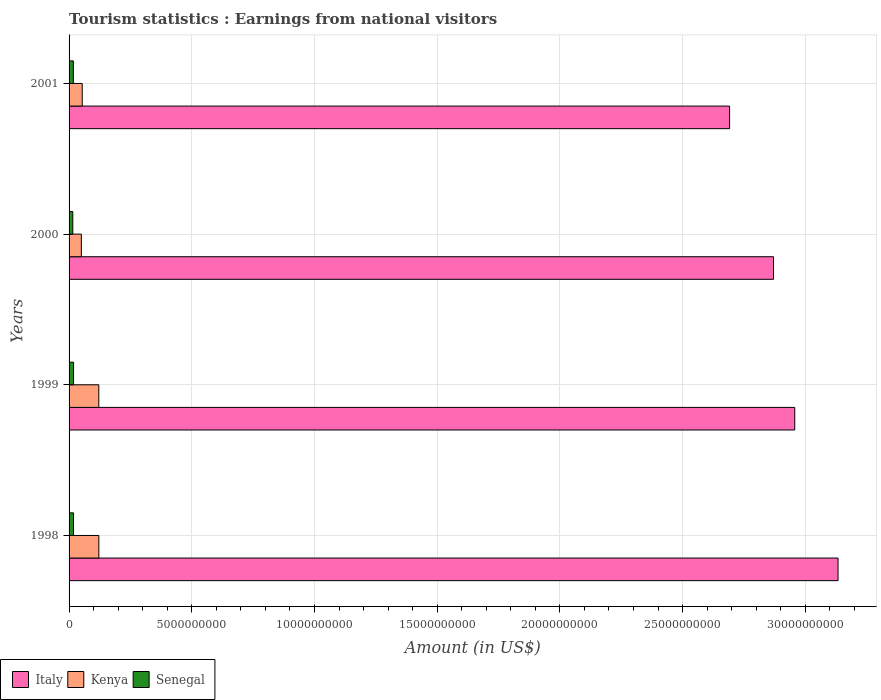Are the number of bars per tick equal to the number of legend labels?
Provide a succinct answer. Yes. Are the number of bars on each tick of the Y-axis equal?
Offer a terse response. Yes. How many bars are there on the 2nd tick from the top?
Provide a succinct answer. 3. In how many cases, is the number of bars for a given year not equal to the number of legend labels?
Give a very brief answer. 0. What is the earnings from national visitors in Kenya in 1999?
Keep it short and to the point. 1.21e+09. Across all years, what is the maximum earnings from national visitors in Italy?
Give a very brief answer. 3.13e+1. Across all years, what is the minimum earnings from national visitors in Senegal?
Keep it short and to the point. 1.52e+08. What is the total earnings from national visitors in Italy in the graph?
Your answer should be very brief. 1.17e+11. What is the difference between the earnings from national visitors in Italy in 1998 and that in 2001?
Offer a very short reply. 4.42e+09. What is the difference between the earnings from national visitors in Kenya in 1999 and the earnings from national visitors in Italy in 2001?
Offer a terse response. -2.57e+1. What is the average earnings from national visitors in Kenya per year?
Offer a very short reply. 8.65e+08. In the year 2001, what is the difference between the earnings from national visitors in Italy and earnings from national visitors in Senegal?
Keep it short and to the point. 2.67e+1. In how many years, is the earnings from national visitors in Kenya greater than 26000000000 US$?
Your answer should be very brief. 0. What is the ratio of the earnings from national visitors in Italy in 1998 to that in 2001?
Offer a terse response. 1.16. What is the difference between the highest and the second highest earnings from national visitors in Italy?
Give a very brief answer. 1.76e+09. What is the difference between the highest and the lowest earnings from national visitors in Italy?
Your response must be concise. 4.42e+09. What does the 3rd bar from the top in 1999 represents?
Keep it short and to the point. Italy. What does the 2nd bar from the bottom in 1998 represents?
Your response must be concise. Kenya. Is it the case that in every year, the sum of the earnings from national visitors in Kenya and earnings from national visitors in Senegal is greater than the earnings from national visitors in Italy?
Make the answer very short. No. Are all the bars in the graph horizontal?
Provide a succinct answer. Yes. What is the difference between two consecutive major ticks on the X-axis?
Make the answer very short. 5.00e+09. Are the values on the major ticks of X-axis written in scientific E-notation?
Make the answer very short. No. Does the graph contain grids?
Keep it short and to the point. Yes. How many legend labels are there?
Ensure brevity in your answer.  3. How are the legend labels stacked?
Provide a succinct answer. Horizontal. What is the title of the graph?
Give a very brief answer. Tourism statistics : Earnings from national visitors. What is the Amount (in US$) of Italy in 1998?
Offer a very short reply. 3.13e+1. What is the Amount (in US$) of Kenya in 1998?
Your answer should be compact. 1.21e+09. What is the Amount (in US$) in Senegal in 1998?
Ensure brevity in your answer.  1.81e+08. What is the Amount (in US$) of Italy in 1999?
Offer a terse response. 2.96e+1. What is the Amount (in US$) in Kenya in 1999?
Your answer should be compact. 1.21e+09. What is the Amount (in US$) in Senegal in 1999?
Provide a short and direct response. 1.83e+08. What is the Amount (in US$) in Italy in 2000?
Provide a succinct answer. 2.87e+1. What is the Amount (in US$) of Senegal in 2000?
Make the answer very short. 1.52e+08. What is the Amount (in US$) of Italy in 2001?
Make the answer very short. 2.69e+1. What is the Amount (in US$) of Kenya in 2001?
Make the answer very short. 5.36e+08. What is the Amount (in US$) in Senegal in 2001?
Ensure brevity in your answer.  1.75e+08. Across all years, what is the maximum Amount (in US$) in Italy?
Offer a very short reply. 3.13e+1. Across all years, what is the maximum Amount (in US$) of Kenya?
Make the answer very short. 1.21e+09. Across all years, what is the maximum Amount (in US$) in Senegal?
Give a very brief answer. 1.83e+08. Across all years, what is the minimum Amount (in US$) of Italy?
Your answer should be very brief. 2.69e+1. Across all years, what is the minimum Amount (in US$) of Kenya?
Keep it short and to the point. 5.00e+08. Across all years, what is the minimum Amount (in US$) in Senegal?
Keep it short and to the point. 1.52e+08. What is the total Amount (in US$) in Italy in the graph?
Offer a terse response. 1.17e+11. What is the total Amount (in US$) in Kenya in the graph?
Your answer should be compact. 3.46e+09. What is the total Amount (in US$) in Senegal in the graph?
Provide a short and direct response. 6.91e+08. What is the difference between the Amount (in US$) of Italy in 1998 and that in 1999?
Provide a short and direct response. 1.76e+09. What is the difference between the Amount (in US$) in Italy in 1998 and that in 2000?
Give a very brief answer. 2.63e+09. What is the difference between the Amount (in US$) of Kenya in 1998 and that in 2000?
Your answer should be compact. 7.13e+08. What is the difference between the Amount (in US$) in Senegal in 1998 and that in 2000?
Your answer should be very brief. 2.90e+07. What is the difference between the Amount (in US$) of Italy in 1998 and that in 2001?
Provide a short and direct response. 4.42e+09. What is the difference between the Amount (in US$) in Kenya in 1998 and that in 2001?
Your response must be concise. 6.77e+08. What is the difference between the Amount (in US$) in Senegal in 1998 and that in 2001?
Provide a short and direct response. 6.00e+06. What is the difference between the Amount (in US$) in Italy in 1999 and that in 2000?
Provide a succinct answer. 8.65e+08. What is the difference between the Amount (in US$) of Kenya in 1999 and that in 2000?
Your response must be concise. 7.11e+08. What is the difference between the Amount (in US$) in Senegal in 1999 and that in 2000?
Your answer should be compact. 3.10e+07. What is the difference between the Amount (in US$) in Italy in 1999 and that in 2001?
Provide a short and direct response. 2.66e+09. What is the difference between the Amount (in US$) of Kenya in 1999 and that in 2001?
Ensure brevity in your answer.  6.75e+08. What is the difference between the Amount (in US$) in Italy in 2000 and that in 2001?
Offer a terse response. 1.79e+09. What is the difference between the Amount (in US$) in Kenya in 2000 and that in 2001?
Ensure brevity in your answer.  -3.60e+07. What is the difference between the Amount (in US$) of Senegal in 2000 and that in 2001?
Give a very brief answer. -2.30e+07. What is the difference between the Amount (in US$) of Italy in 1998 and the Amount (in US$) of Kenya in 1999?
Your answer should be compact. 3.01e+1. What is the difference between the Amount (in US$) of Italy in 1998 and the Amount (in US$) of Senegal in 1999?
Provide a short and direct response. 3.12e+1. What is the difference between the Amount (in US$) of Kenya in 1998 and the Amount (in US$) of Senegal in 1999?
Your response must be concise. 1.03e+09. What is the difference between the Amount (in US$) of Italy in 1998 and the Amount (in US$) of Kenya in 2000?
Ensure brevity in your answer.  3.08e+1. What is the difference between the Amount (in US$) in Italy in 1998 and the Amount (in US$) in Senegal in 2000?
Your answer should be compact. 3.12e+1. What is the difference between the Amount (in US$) in Kenya in 1998 and the Amount (in US$) in Senegal in 2000?
Keep it short and to the point. 1.06e+09. What is the difference between the Amount (in US$) of Italy in 1998 and the Amount (in US$) of Kenya in 2001?
Provide a short and direct response. 3.08e+1. What is the difference between the Amount (in US$) of Italy in 1998 and the Amount (in US$) of Senegal in 2001?
Offer a terse response. 3.12e+1. What is the difference between the Amount (in US$) in Kenya in 1998 and the Amount (in US$) in Senegal in 2001?
Keep it short and to the point. 1.04e+09. What is the difference between the Amount (in US$) in Italy in 1999 and the Amount (in US$) in Kenya in 2000?
Your response must be concise. 2.91e+1. What is the difference between the Amount (in US$) in Italy in 1999 and the Amount (in US$) in Senegal in 2000?
Provide a short and direct response. 2.94e+1. What is the difference between the Amount (in US$) in Kenya in 1999 and the Amount (in US$) in Senegal in 2000?
Your answer should be very brief. 1.06e+09. What is the difference between the Amount (in US$) of Italy in 1999 and the Amount (in US$) of Kenya in 2001?
Make the answer very short. 2.90e+1. What is the difference between the Amount (in US$) of Italy in 1999 and the Amount (in US$) of Senegal in 2001?
Your response must be concise. 2.94e+1. What is the difference between the Amount (in US$) of Kenya in 1999 and the Amount (in US$) of Senegal in 2001?
Your answer should be very brief. 1.04e+09. What is the difference between the Amount (in US$) in Italy in 2000 and the Amount (in US$) in Kenya in 2001?
Offer a very short reply. 2.82e+1. What is the difference between the Amount (in US$) of Italy in 2000 and the Amount (in US$) of Senegal in 2001?
Ensure brevity in your answer.  2.85e+1. What is the difference between the Amount (in US$) of Kenya in 2000 and the Amount (in US$) of Senegal in 2001?
Provide a succinct answer. 3.25e+08. What is the average Amount (in US$) of Italy per year?
Ensure brevity in your answer.  2.91e+1. What is the average Amount (in US$) in Kenya per year?
Give a very brief answer. 8.65e+08. What is the average Amount (in US$) of Senegal per year?
Offer a terse response. 1.73e+08. In the year 1998, what is the difference between the Amount (in US$) of Italy and Amount (in US$) of Kenya?
Offer a very short reply. 3.01e+1. In the year 1998, what is the difference between the Amount (in US$) in Italy and Amount (in US$) in Senegal?
Ensure brevity in your answer.  3.12e+1. In the year 1998, what is the difference between the Amount (in US$) of Kenya and Amount (in US$) of Senegal?
Keep it short and to the point. 1.03e+09. In the year 1999, what is the difference between the Amount (in US$) in Italy and Amount (in US$) in Kenya?
Ensure brevity in your answer.  2.84e+1. In the year 1999, what is the difference between the Amount (in US$) of Italy and Amount (in US$) of Senegal?
Give a very brief answer. 2.94e+1. In the year 1999, what is the difference between the Amount (in US$) of Kenya and Amount (in US$) of Senegal?
Keep it short and to the point. 1.03e+09. In the year 2000, what is the difference between the Amount (in US$) in Italy and Amount (in US$) in Kenya?
Offer a terse response. 2.82e+1. In the year 2000, what is the difference between the Amount (in US$) of Italy and Amount (in US$) of Senegal?
Offer a terse response. 2.86e+1. In the year 2000, what is the difference between the Amount (in US$) in Kenya and Amount (in US$) in Senegal?
Your answer should be very brief. 3.48e+08. In the year 2001, what is the difference between the Amount (in US$) of Italy and Amount (in US$) of Kenya?
Provide a short and direct response. 2.64e+1. In the year 2001, what is the difference between the Amount (in US$) of Italy and Amount (in US$) of Senegal?
Provide a short and direct response. 2.67e+1. In the year 2001, what is the difference between the Amount (in US$) of Kenya and Amount (in US$) of Senegal?
Provide a succinct answer. 3.61e+08. What is the ratio of the Amount (in US$) in Italy in 1998 to that in 1999?
Give a very brief answer. 1.06. What is the ratio of the Amount (in US$) in Kenya in 1998 to that in 1999?
Provide a short and direct response. 1. What is the ratio of the Amount (in US$) of Senegal in 1998 to that in 1999?
Your answer should be compact. 0.99. What is the ratio of the Amount (in US$) in Italy in 1998 to that in 2000?
Your response must be concise. 1.09. What is the ratio of the Amount (in US$) in Kenya in 1998 to that in 2000?
Provide a succinct answer. 2.43. What is the ratio of the Amount (in US$) in Senegal in 1998 to that in 2000?
Offer a very short reply. 1.19. What is the ratio of the Amount (in US$) of Italy in 1998 to that in 2001?
Your answer should be very brief. 1.16. What is the ratio of the Amount (in US$) of Kenya in 1998 to that in 2001?
Give a very brief answer. 2.26. What is the ratio of the Amount (in US$) of Senegal in 1998 to that in 2001?
Ensure brevity in your answer.  1.03. What is the ratio of the Amount (in US$) in Italy in 1999 to that in 2000?
Provide a succinct answer. 1.03. What is the ratio of the Amount (in US$) in Kenya in 1999 to that in 2000?
Keep it short and to the point. 2.42. What is the ratio of the Amount (in US$) of Senegal in 1999 to that in 2000?
Provide a succinct answer. 1.2. What is the ratio of the Amount (in US$) in Italy in 1999 to that in 2001?
Make the answer very short. 1.1. What is the ratio of the Amount (in US$) of Kenya in 1999 to that in 2001?
Your answer should be compact. 2.26. What is the ratio of the Amount (in US$) of Senegal in 1999 to that in 2001?
Provide a short and direct response. 1.05. What is the ratio of the Amount (in US$) of Italy in 2000 to that in 2001?
Your answer should be very brief. 1.07. What is the ratio of the Amount (in US$) in Kenya in 2000 to that in 2001?
Give a very brief answer. 0.93. What is the ratio of the Amount (in US$) of Senegal in 2000 to that in 2001?
Your answer should be compact. 0.87. What is the difference between the highest and the second highest Amount (in US$) of Italy?
Provide a short and direct response. 1.76e+09. What is the difference between the highest and the second highest Amount (in US$) in Kenya?
Keep it short and to the point. 2.00e+06. What is the difference between the highest and the second highest Amount (in US$) in Senegal?
Offer a very short reply. 2.00e+06. What is the difference between the highest and the lowest Amount (in US$) in Italy?
Give a very brief answer. 4.42e+09. What is the difference between the highest and the lowest Amount (in US$) of Kenya?
Provide a short and direct response. 7.13e+08. What is the difference between the highest and the lowest Amount (in US$) of Senegal?
Give a very brief answer. 3.10e+07. 